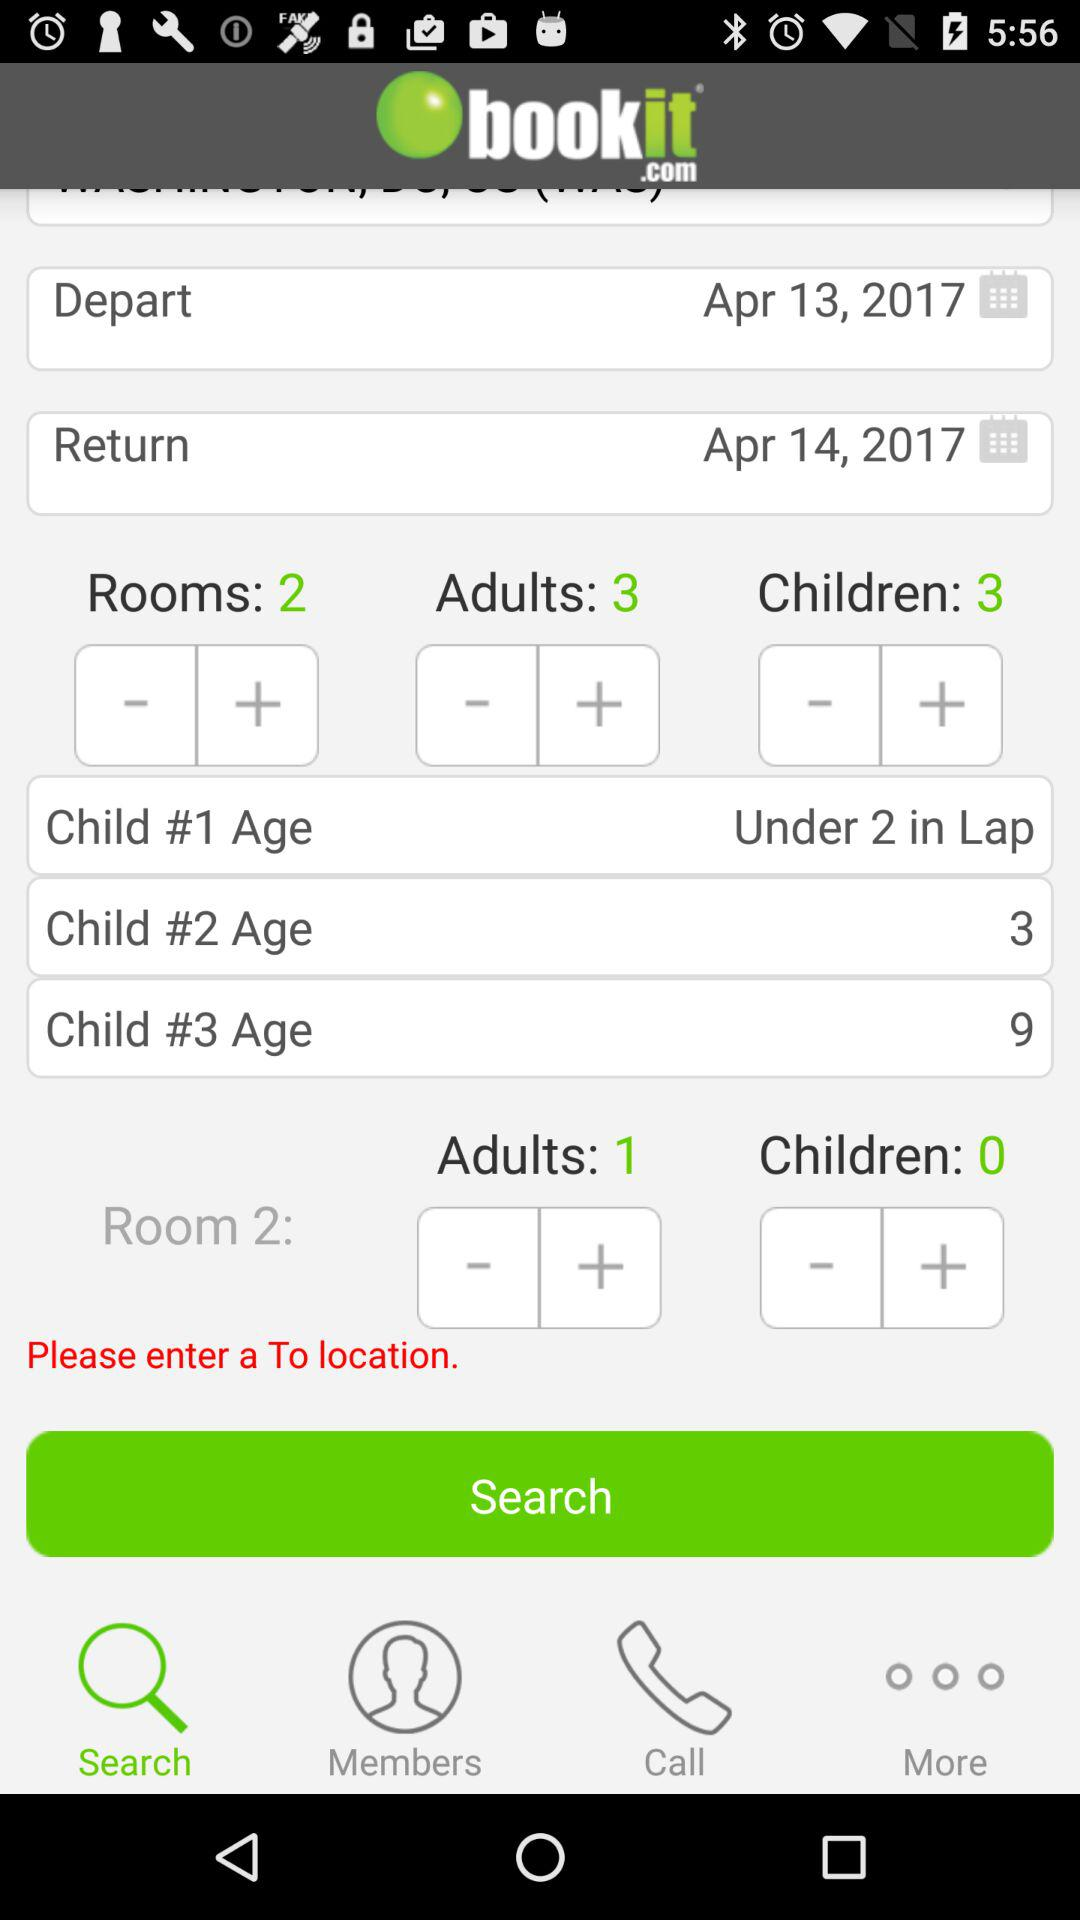What is the total number of children? The total number of children is 3. 